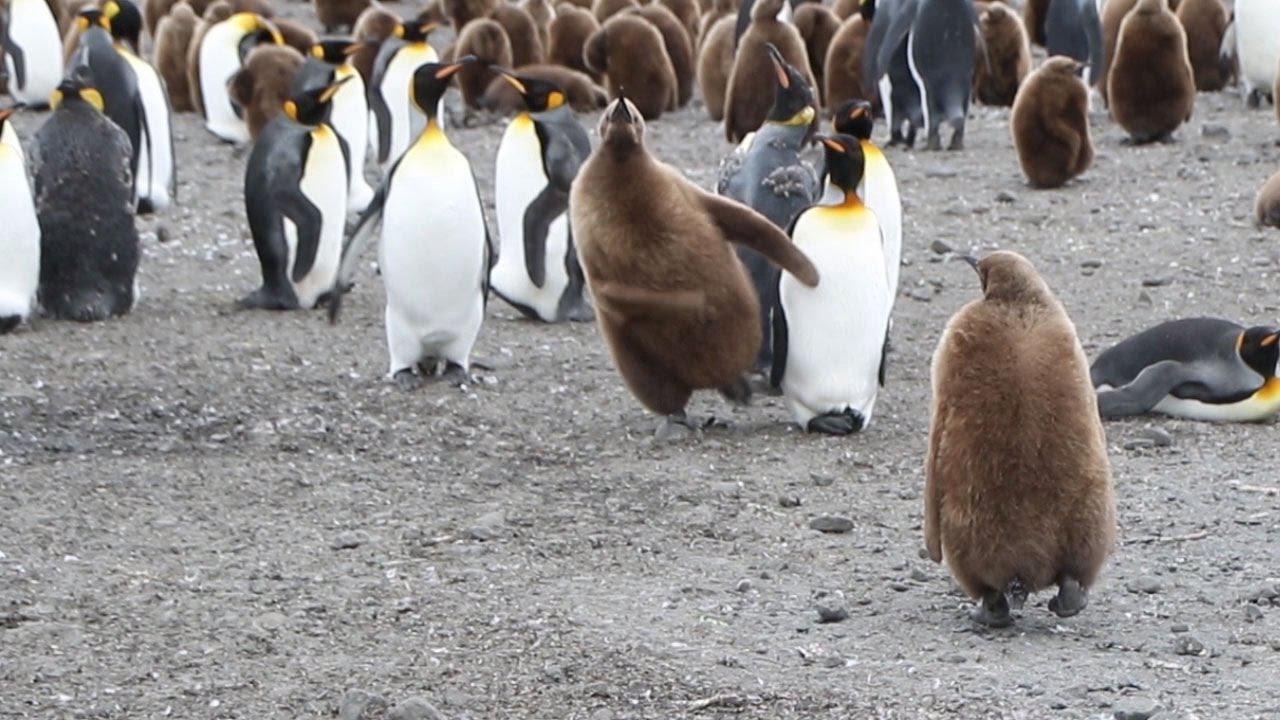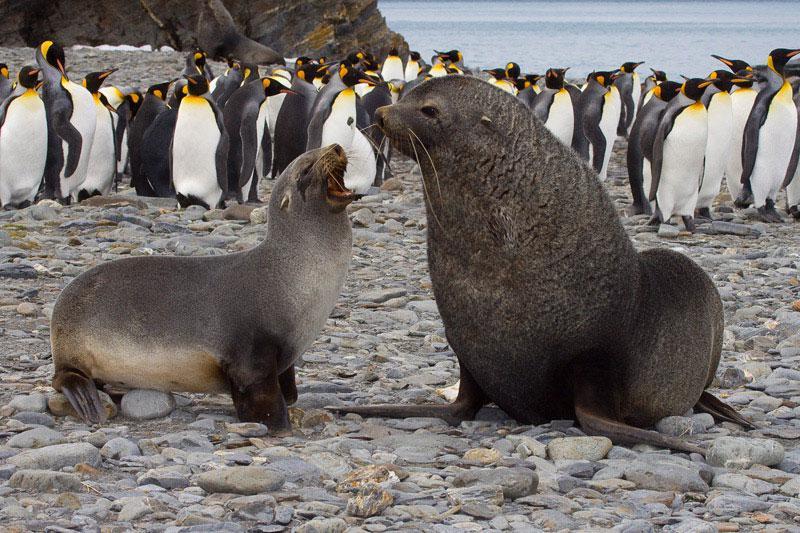The first image is the image on the left, the second image is the image on the right. Given the left and right images, does the statement "In the right image, a fuzzy brown penguin stands by itself, with other penguins in the background." hold true? Answer yes or no. No. The first image is the image on the left, the second image is the image on the right. Evaluate the accuracy of this statement regarding the images: "One of the images contains visible grass.". Is it true? Answer yes or no. No. 